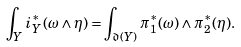Convert formula to latex. <formula><loc_0><loc_0><loc_500><loc_500>\int _ { Y } i _ { Y } ^ { * } ( \omega \wedge \eta ) = \int _ { \mathfrak { d } ( Y ) } \pi _ { 1 } ^ { * } ( \omega ) \wedge \pi _ { 2 } ^ { * } ( \eta ) .</formula> 